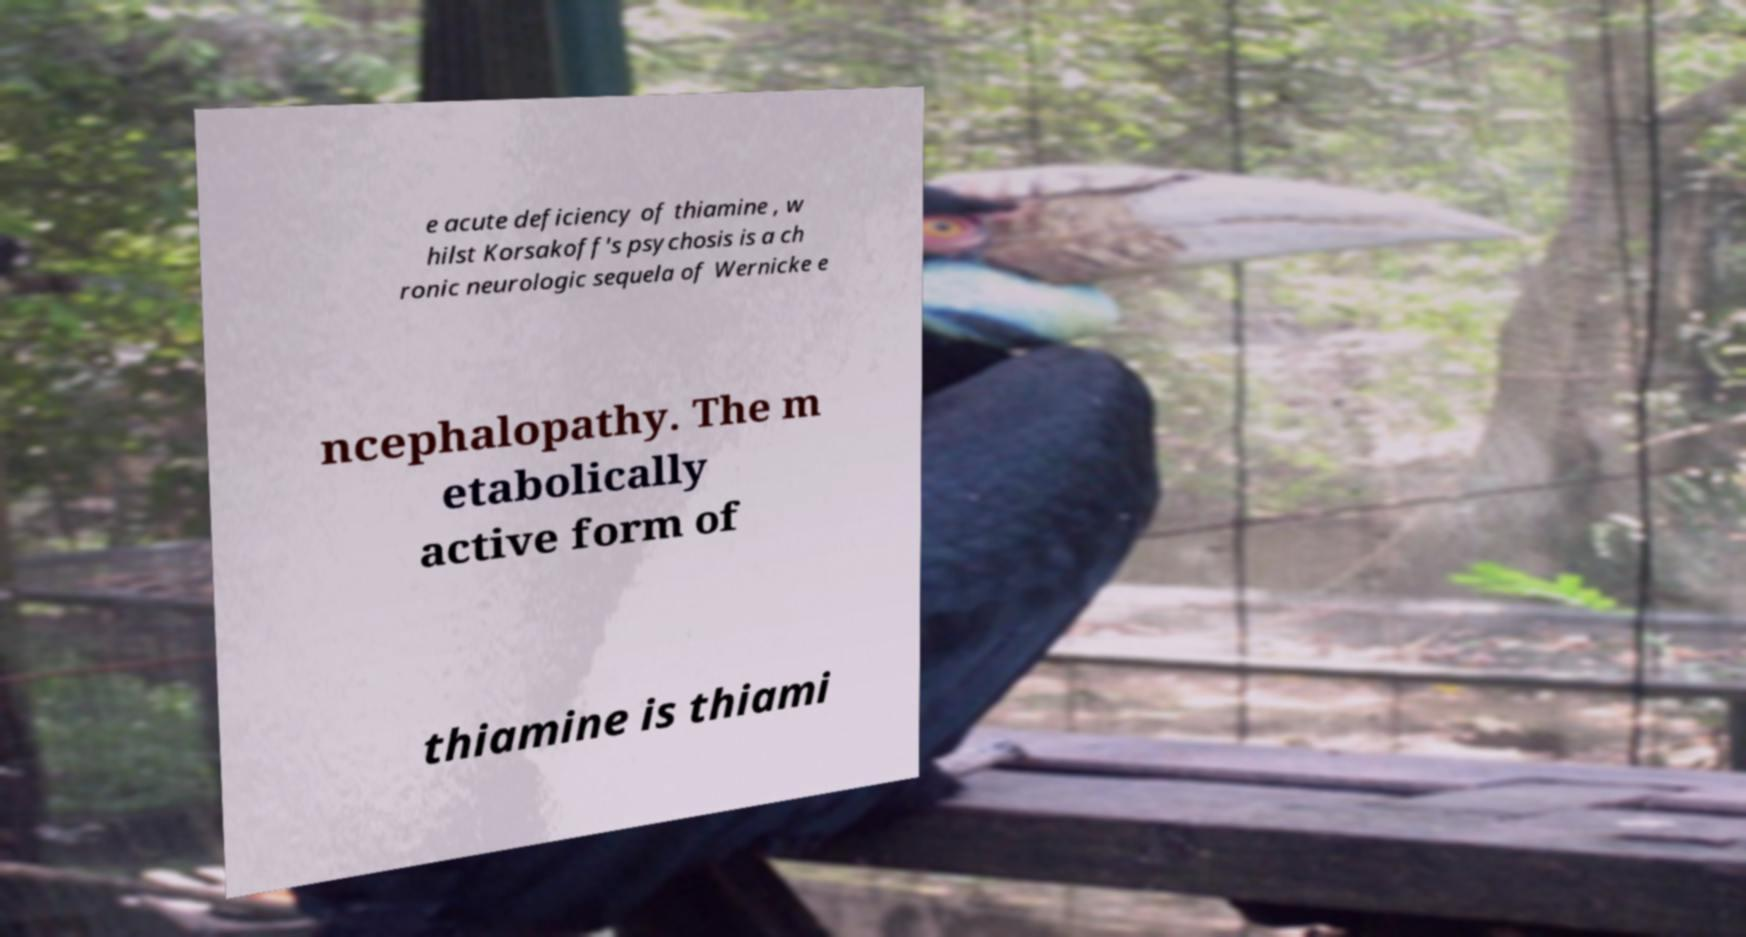Can you read and provide the text displayed in the image?This photo seems to have some interesting text. Can you extract and type it out for me? e acute deficiency of thiamine , w hilst Korsakoff's psychosis is a ch ronic neurologic sequela of Wernicke e ncephalopathy. The m etabolically active form of thiamine is thiami 